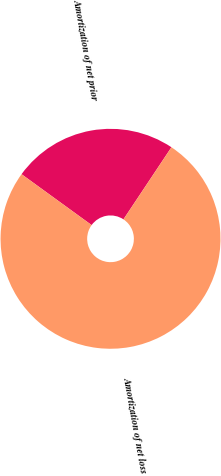Convert chart to OTSL. <chart><loc_0><loc_0><loc_500><loc_500><pie_chart><fcel>Amortization of net prior<fcel>Amortization of net loss<nl><fcel>24.35%<fcel>75.65%<nl></chart> 